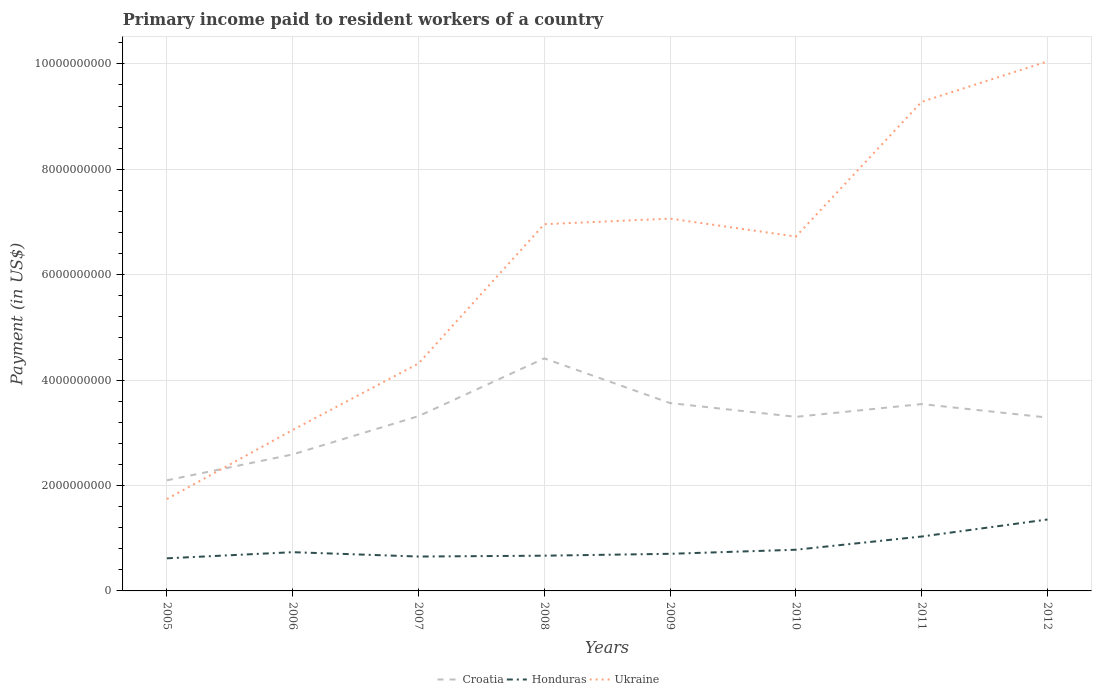How many different coloured lines are there?
Keep it short and to the point. 3. Is the number of lines equal to the number of legend labels?
Offer a terse response. Yes. Across all years, what is the maximum amount paid to workers in Ukraine?
Offer a very short reply. 1.74e+09. In which year was the amount paid to workers in Honduras maximum?
Make the answer very short. 2005. What is the total amount paid to workers in Ukraine in the graph?
Provide a succinct answer. -3.32e+09. What is the difference between the highest and the second highest amount paid to workers in Ukraine?
Your response must be concise. 8.30e+09. What is the difference between the highest and the lowest amount paid to workers in Honduras?
Ensure brevity in your answer.  2. How many years are there in the graph?
Offer a very short reply. 8. Are the values on the major ticks of Y-axis written in scientific E-notation?
Your answer should be compact. No. Does the graph contain any zero values?
Your response must be concise. No. How are the legend labels stacked?
Your answer should be compact. Horizontal. What is the title of the graph?
Your answer should be compact. Primary income paid to resident workers of a country. What is the label or title of the X-axis?
Your response must be concise. Years. What is the label or title of the Y-axis?
Keep it short and to the point. Payment (in US$). What is the Payment (in US$) in Croatia in 2005?
Your answer should be compact. 2.10e+09. What is the Payment (in US$) of Honduras in 2005?
Your answer should be compact. 6.19e+08. What is the Payment (in US$) of Ukraine in 2005?
Ensure brevity in your answer.  1.74e+09. What is the Payment (in US$) in Croatia in 2006?
Your answer should be compact. 2.59e+09. What is the Payment (in US$) of Honduras in 2006?
Offer a terse response. 7.35e+08. What is the Payment (in US$) in Ukraine in 2006?
Offer a very short reply. 3.05e+09. What is the Payment (in US$) in Croatia in 2007?
Your answer should be very brief. 3.32e+09. What is the Payment (in US$) of Honduras in 2007?
Keep it short and to the point. 6.52e+08. What is the Payment (in US$) in Ukraine in 2007?
Ensure brevity in your answer.  4.32e+09. What is the Payment (in US$) of Croatia in 2008?
Offer a terse response. 4.41e+09. What is the Payment (in US$) in Honduras in 2008?
Your response must be concise. 6.69e+08. What is the Payment (in US$) of Ukraine in 2008?
Give a very brief answer. 6.96e+09. What is the Payment (in US$) in Croatia in 2009?
Your response must be concise. 3.56e+09. What is the Payment (in US$) of Honduras in 2009?
Ensure brevity in your answer.  7.04e+08. What is the Payment (in US$) of Ukraine in 2009?
Provide a short and direct response. 7.06e+09. What is the Payment (in US$) of Croatia in 2010?
Offer a terse response. 3.30e+09. What is the Payment (in US$) of Honduras in 2010?
Offer a very short reply. 7.81e+08. What is the Payment (in US$) of Ukraine in 2010?
Make the answer very short. 6.72e+09. What is the Payment (in US$) in Croatia in 2011?
Offer a terse response. 3.55e+09. What is the Payment (in US$) of Honduras in 2011?
Offer a very short reply. 1.03e+09. What is the Payment (in US$) in Ukraine in 2011?
Give a very brief answer. 9.28e+09. What is the Payment (in US$) in Croatia in 2012?
Make the answer very short. 3.29e+09. What is the Payment (in US$) in Honduras in 2012?
Give a very brief answer. 1.36e+09. What is the Payment (in US$) of Ukraine in 2012?
Offer a very short reply. 1.00e+1. Across all years, what is the maximum Payment (in US$) of Croatia?
Your answer should be very brief. 4.41e+09. Across all years, what is the maximum Payment (in US$) of Honduras?
Your answer should be compact. 1.36e+09. Across all years, what is the maximum Payment (in US$) of Ukraine?
Provide a succinct answer. 1.00e+1. Across all years, what is the minimum Payment (in US$) of Croatia?
Give a very brief answer. 2.10e+09. Across all years, what is the minimum Payment (in US$) in Honduras?
Your answer should be very brief. 6.19e+08. Across all years, what is the minimum Payment (in US$) in Ukraine?
Provide a succinct answer. 1.74e+09. What is the total Payment (in US$) in Croatia in the graph?
Ensure brevity in your answer.  2.61e+1. What is the total Payment (in US$) in Honduras in the graph?
Your answer should be very brief. 6.55e+09. What is the total Payment (in US$) in Ukraine in the graph?
Your answer should be very brief. 4.92e+1. What is the difference between the Payment (in US$) in Croatia in 2005 and that in 2006?
Your response must be concise. -4.92e+08. What is the difference between the Payment (in US$) of Honduras in 2005 and that in 2006?
Offer a terse response. -1.16e+08. What is the difference between the Payment (in US$) in Ukraine in 2005 and that in 2006?
Provide a short and direct response. -1.31e+09. What is the difference between the Payment (in US$) in Croatia in 2005 and that in 2007?
Provide a succinct answer. -1.22e+09. What is the difference between the Payment (in US$) of Honduras in 2005 and that in 2007?
Your answer should be very brief. -3.38e+07. What is the difference between the Payment (in US$) in Ukraine in 2005 and that in 2007?
Your response must be concise. -2.57e+09. What is the difference between the Payment (in US$) of Croatia in 2005 and that in 2008?
Your answer should be compact. -2.31e+09. What is the difference between the Payment (in US$) of Honduras in 2005 and that in 2008?
Your answer should be very brief. -5.00e+07. What is the difference between the Payment (in US$) in Ukraine in 2005 and that in 2008?
Your answer should be very brief. -5.22e+09. What is the difference between the Payment (in US$) of Croatia in 2005 and that in 2009?
Your answer should be very brief. -1.47e+09. What is the difference between the Payment (in US$) of Honduras in 2005 and that in 2009?
Your response must be concise. -8.54e+07. What is the difference between the Payment (in US$) in Ukraine in 2005 and that in 2009?
Keep it short and to the point. -5.32e+09. What is the difference between the Payment (in US$) in Croatia in 2005 and that in 2010?
Your answer should be compact. -1.20e+09. What is the difference between the Payment (in US$) of Honduras in 2005 and that in 2010?
Offer a very short reply. -1.63e+08. What is the difference between the Payment (in US$) of Ukraine in 2005 and that in 2010?
Offer a terse response. -4.98e+09. What is the difference between the Payment (in US$) in Croatia in 2005 and that in 2011?
Offer a terse response. -1.45e+09. What is the difference between the Payment (in US$) in Honduras in 2005 and that in 2011?
Your response must be concise. -4.14e+08. What is the difference between the Payment (in US$) in Ukraine in 2005 and that in 2011?
Provide a succinct answer. -7.54e+09. What is the difference between the Payment (in US$) in Croatia in 2005 and that in 2012?
Your answer should be very brief. -1.19e+09. What is the difference between the Payment (in US$) in Honduras in 2005 and that in 2012?
Offer a terse response. -7.37e+08. What is the difference between the Payment (in US$) in Ukraine in 2005 and that in 2012?
Offer a terse response. -8.30e+09. What is the difference between the Payment (in US$) of Croatia in 2006 and that in 2007?
Ensure brevity in your answer.  -7.26e+08. What is the difference between the Payment (in US$) of Honduras in 2006 and that in 2007?
Your response must be concise. 8.26e+07. What is the difference between the Payment (in US$) of Ukraine in 2006 and that in 2007?
Keep it short and to the point. -1.26e+09. What is the difference between the Payment (in US$) in Croatia in 2006 and that in 2008?
Provide a succinct answer. -1.82e+09. What is the difference between the Payment (in US$) in Honduras in 2006 and that in 2008?
Your answer should be very brief. 6.64e+07. What is the difference between the Payment (in US$) in Ukraine in 2006 and that in 2008?
Give a very brief answer. -3.90e+09. What is the difference between the Payment (in US$) of Croatia in 2006 and that in 2009?
Give a very brief answer. -9.74e+08. What is the difference between the Payment (in US$) of Honduras in 2006 and that in 2009?
Offer a very short reply. 3.09e+07. What is the difference between the Payment (in US$) in Ukraine in 2006 and that in 2009?
Keep it short and to the point. -4.01e+09. What is the difference between the Payment (in US$) in Croatia in 2006 and that in 2010?
Your answer should be very brief. -7.13e+08. What is the difference between the Payment (in US$) of Honduras in 2006 and that in 2010?
Make the answer very short. -4.64e+07. What is the difference between the Payment (in US$) in Ukraine in 2006 and that in 2010?
Your answer should be very brief. -3.67e+09. What is the difference between the Payment (in US$) of Croatia in 2006 and that in 2011?
Your response must be concise. -9.55e+08. What is the difference between the Payment (in US$) in Honduras in 2006 and that in 2011?
Make the answer very short. -2.97e+08. What is the difference between the Payment (in US$) of Ukraine in 2006 and that in 2011?
Your answer should be compact. -6.23e+09. What is the difference between the Payment (in US$) in Croatia in 2006 and that in 2012?
Your answer should be compact. -7.00e+08. What is the difference between the Payment (in US$) of Honduras in 2006 and that in 2012?
Offer a terse response. -6.20e+08. What is the difference between the Payment (in US$) of Ukraine in 2006 and that in 2012?
Ensure brevity in your answer.  -6.99e+09. What is the difference between the Payment (in US$) in Croatia in 2007 and that in 2008?
Your answer should be compact. -1.10e+09. What is the difference between the Payment (in US$) of Honduras in 2007 and that in 2008?
Give a very brief answer. -1.62e+07. What is the difference between the Payment (in US$) in Ukraine in 2007 and that in 2008?
Offer a very short reply. -2.64e+09. What is the difference between the Payment (in US$) in Croatia in 2007 and that in 2009?
Give a very brief answer. -2.48e+08. What is the difference between the Payment (in US$) of Honduras in 2007 and that in 2009?
Offer a very short reply. -5.17e+07. What is the difference between the Payment (in US$) in Ukraine in 2007 and that in 2009?
Make the answer very short. -2.75e+09. What is the difference between the Payment (in US$) in Croatia in 2007 and that in 2010?
Offer a very short reply. 1.30e+07. What is the difference between the Payment (in US$) in Honduras in 2007 and that in 2010?
Make the answer very short. -1.29e+08. What is the difference between the Payment (in US$) of Ukraine in 2007 and that in 2010?
Offer a terse response. -2.41e+09. What is the difference between the Payment (in US$) in Croatia in 2007 and that in 2011?
Your answer should be very brief. -2.30e+08. What is the difference between the Payment (in US$) in Honduras in 2007 and that in 2011?
Your answer should be very brief. -3.80e+08. What is the difference between the Payment (in US$) of Ukraine in 2007 and that in 2011?
Your answer should be compact. -4.97e+09. What is the difference between the Payment (in US$) of Croatia in 2007 and that in 2012?
Offer a terse response. 2.61e+07. What is the difference between the Payment (in US$) in Honduras in 2007 and that in 2012?
Ensure brevity in your answer.  -7.03e+08. What is the difference between the Payment (in US$) of Ukraine in 2007 and that in 2012?
Provide a succinct answer. -5.73e+09. What is the difference between the Payment (in US$) in Croatia in 2008 and that in 2009?
Your response must be concise. 8.48e+08. What is the difference between the Payment (in US$) of Honduras in 2008 and that in 2009?
Ensure brevity in your answer.  -3.55e+07. What is the difference between the Payment (in US$) of Ukraine in 2008 and that in 2009?
Your answer should be very brief. -1.05e+08. What is the difference between the Payment (in US$) of Croatia in 2008 and that in 2010?
Your answer should be very brief. 1.11e+09. What is the difference between the Payment (in US$) of Honduras in 2008 and that in 2010?
Keep it short and to the point. -1.13e+08. What is the difference between the Payment (in US$) in Ukraine in 2008 and that in 2010?
Provide a succinct answer. 2.35e+08. What is the difference between the Payment (in US$) of Croatia in 2008 and that in 2011?
Offer a very short reply. 8.67e+08. What is the difference between the Payment (in US$) in Honduras in 2008 and that in 2011?
Keep it short and to the point. -3.64e+08. What is the difference between the Payment (in US$) of Ukraine in 2008 and that in 2011?
Your answer should be very brief. -2.32e+09. What is the difference between the Payment (in US$) in Croatia in 2008 and that in 2012?
Make the answer very short. 1.12e+09. What is the difference between the Payment (in US$) in Honduras in 2008 and that in 2012?
Your response must be concise. -6.87e+08. What is the difference between the Payment (in US$) of Ukraine in 2008 and that in 2012?
Make the answer very short. -3.09e+09. What is the difference between the Payment (in US$) of Croatia in 2009 and that in 2010?
Provide a short and direct response. 2.61e+08. What is the difference between the Payment (in US$) in Honduras in 2009 and that in 2010?
Your answer should be very brief. -7.73e+07. What is the difference between the Payment (in US$) in Ukraine in 2009 and that in 2010?
Make the answer very short. 3.40e+08. What is the difference between the Payment (in US$) of Croatia in 2009 and that in 2011?
Offer a terse response. 1.87e+07. What is the difference between the Payment (in US$) of Honduras in 2009 and that in 2011?
Offer a very short reply. -3.28e+08. What is the difference between the Payment (in US$) in Ukraine in 2009 and that in 2011?
Make the answer very short. -2.22e+09. What is the difference between the Payment (in US$) in Croatia in 2009 and that in 2012?
Offer a terse response. 2.74e+08. What is the difference between the Payment (in US$) in Honduras in 2009 and that in 2012?
Provide a succinct answer. -6.51e+08. What is the difference between the Payment (in US$) in Ukraine in 2009 and that in 2012?
Provide a succinct answer. -2.98e+09. What is the difference between the Payment (in US$) in Croatia in 2010 and that in 2011?
Your answer should be very brief. -2.43e+08. What is the difference between the Payment (in US$) of Honduras in 2010 and that in 2011?
Offer a very short reply. -2.51e+08. What is the difference between the Payment (in US$) in Ukraine in 2010 and that in 2011?
Keep it short and to the point. -2.56e+09. What is the difference between the Payment (in US$) in Croatia in 2010 and that in 2012?
Your answer should be compact. 1.30e+07. What is the difference between the Payment (in US$) of Honduras in 2010 and that in 2012?
Give a very brief answer. -5.74e+08. What is the difference between the Payment (in US$) of Ukraine in 2010 and that in 2012?
Provide a succinct answer. -3.32e+09. What is the difference between the Payment (in US$) in Croatia in 2011 and that in 2012?
Keep it short and to the point. 2.56e+08. What is the difference between the Payment (in US$) of Honduras in 2011 and that in 2012?
Your response must be concise. -3.23e+08. What is the difference between the Payment (in US$) in Ukraine in 2011 and that in 2012?
Provide a succinct answer. -7.66e+08. What is the difference between the Payment (in US$) of Croatia in 2005 and the Payment (in US$) of Honduras in 2006?
Your answer should be very brief. 1.36e+09. What is the difference between the Payment (in US$) of Croatia in 2005 and the Payment (in US$) of Ukraine in 2006?
Offer a very short reply. -9.55e+08. What is the difference between the Payment (in US$) of Honduras in 2005 and the Payment (in US$) of Ukraine in 2006?
Make the answer very short. -2.44e+09. What is the difference between the Payment (in US$) of Croatia in 2005 and the Payment (in US$) of Honduras in 2007?
Make the answer very short. 1.45e+09. What is the difference between the Payment (in US$) of Croatia in 2005 and the Payment (in US$) of Ukraine in 2007?
Ensure brevity in your answer.  -2.22e+09. What is the difference between the Payment (in US$) in Honduras in 2005 and the Payment (in US$) in Ukraine in 2007?
Keep it short and to the point. -3.70e+09. What is the difference between the Payment (in US$) in Croatia in 2005 and the Payment (in US$) in Honduras in 2008?
Your answer should be compact. 1.43e+09. What is the difference between the Payment (in US$) of Croatia in 2005 and the Payment (in US$) of Ukraine in 2008?
Provide a short and direct response. -4.86e+09. What is the difference between the Payment (in US$) in Honduras in 2005 and the Payment (in US$) in Ukraine in 2008?
Your answer should be very brief. -6.34e+09. What is the difference between the Payment (in US$) of Croatia in 2005 and the Payment (in US$) of Honduras in 2009?
Your response must be concise. 1.39e+09. What is the difference between the Payment (in US$) of Croatia in 2005 and the Payment (in US$) of Ukraine in 2009?
Your answer should be compact. -4.97e+09. What is the difference between the Payment (in US$) in Honduras in 2005 and the Payment (in US$) in Ukraine in 2009?
Your response must be concise. -6.45e+09. What is the difference between the Payment (in US$) in Croatia in 2005 and the Payment (in US$) in Honduras in 2010?
Offer a terse response. 1.32e+09. What is the difference between the Payment (in US$) of Croatia in 2005 and the Payment (in US$) of Ukraine in 2010?
Your response must be concise. -4.63e+09. What is the difference between the Payment (in US$) in Honduras in 2005 and the Payment (in US$) in Ukraine in 2010?
Your response must be concise. -6.11e+09. What is the difference between the Payment (in US$) of Croatia in 2005 and the Payment (in US$) of Honduras in 2011?
Your answer should be compact. 1.07e+09. What is the difference between the Payment (in US$) of Croatia in 2005 and the Payment (in US$) of Ukraine in 2011?
Make the answer very short. -7.18e+09. What is the difference between the Payment (in US$) in Honduras in 2005 and the Payment (in US$) in Ukraine in 2011?
Your response must be concise. -8.66e+09. What is the difference between the Payment (in US$) of Croatia in 2005 and the Payment (in US$) of Honduras in 2012?
Your response must be concise. 7.43e+08. What is the difference between the Payment (in US$) of Croatia in 2005 and the Payment (in US$) of Ukraine in 2012?
Provide a succinct answer. -7.95e+09. What is the difference between the Payment (in US$) in Honduras in 2005 and the Payment (in US$) in Ukraine in 2012?
Your response must be concise. -9.43e+09. What is the difference between the Payment (in US$) in Croatia in 2006 and the Payment (in US$) in Honduras in 2007?
Keep it short and to the point. 1.94e+09. What is the difference between the Payment (in US$) in Croatia in 2006 and the Payment (in US$) in Ukraine in 2007?
Make the answer very short. -1.72e+09. What is the difference between the Payment (in US$) of Honduras in 2006 and the Payment (in US$) of Ukraine in 2007?
Your answer should be compact. -3.58e+09. What is the difference between the Payment (in US$) in Croatia in 2006 and the Payment (in US$) in Honduras in 2008?
Make the answer very short. 1.92e+09. What is the difference between the Payment (in US$) of Croatia in 2006 and the Payment (in US$) of Ukraine in 2008?
Provide a succinct answer. -4.37e+09. What is the difference between the Payment (in US$) in Honduras in 2006 and the Payment (in US$) in Ukraine in 2008?
Ensure brevity in your answer.  -6.22e+09. What is the difference between the Payment (in US$) of Croatia in 2006 and the Payment (in US$) of Honduras in 2009?
Your answer should be compact. 1.89e+09. What is the difference between the Payment (in US$) of Croatia in 2006 and the Payment (in US$) of Ukraine in 2009?
Offer a terse response. -4.47e+09. What is the difference between the Payment (in US$) of Honduras in 2006 and the Payment (in US$) of Ukraine in 2009?
Your response must be concise. -6.33e+09. What is the difference between the Payment (in US$) of Croatia in 2006 and the Payment (in US$) of Honduras in 2010?
Offer a very short reply. 1.81e+09. What is the difference between the Payment (in US$) of Croatia in 2006 and the Payment (in US$) of Ukraine in 2010?
Offer a terse response. -4.13e+09. What is the difference between the Payment (in US$) of Honduras in 2006 and the Payment (in US$) of Ukraine in 2010?
Make the answer very short. -5.99e+09. What is the difference between the Payment (in US$) of Croatia in 2006 and the Payment (in US$) of Honduras in 2011?
Give a very brief answer. 1.56e+09. What is the difference between the Payment (in US$) of Croatia in 2006 and the Payment (in US$) of Ukraine in 2011?
Provide a succinct answer. -6.69e+09. What is the difference between the Payment (in US$) in Honduras in 2006 and the Payment (in US$) in Ukraine in 2011?
Your response must be concise. -8.55e+09. What is the difference between the Payment (in US$) in Croatia in 2006 and the Payment (in US$) in Honduras in 2012?
Ensure brevity in your answer.  1.23e+09. What is the difference between the Payment (in US$) in Croatia in 2006 and the Payment (in US$) in Ukraine in 2012?
Give a very brief answer. -7.46e+09. What is the difference between the Payment (in US$) in Honduras in 2006 and the Payment (in US$) in Ukraine in 2012?
Offer a terse response. -9.31e+09. What is the difference between the Payment (in US$) of Croatia in 2007 and the Payment (in US$) of Honduras in 2008?
Keep it short and to the point. 2.65e+09. What is the difference between the Payment (in US$) of Croatia in 2007 and the Payment (in US$) of Ukraine in 2008?
Give a very brief answer. -3.64e+09. What is the difference between the Payment (in US$) in Honduras in 2007 and the Payment (in US$) in Ukraine in 2008?
Offer a terse response. -6.31e+09. What is the difference between the Payment (in US$) in Croatia in 2007 and the Payment (in US$) in Honduras in 2009?
Ensure brevity in your answer.  2.61e+09. What is the difference between the Payment (in US$) of Croatia in 2007 and the Payment (in US$) of Ukraine in 2009?
Keep it short and to the point. -3.75e+09. What is the difference between the Payment (in US$) of Honduras in 2007 and the Payment (in US$) of Ukraine in 2009?
Your response must be concise. -6.41e+09. What is the difference between the Payment (in US$) in Croatia in 2007 and the Payment (in US$) in Honduras in 2010?
Give a very brief answer. 2.53e+09. What is the difference between the Payment (in US$) of Croatia in 2007 and the Payment (in US$) of Ukraine in 2010?
Offer a terse response. -3.41e+09. What is the difference between the Payment (in US$) of Honduras in 2007 and the Payment (in US$) of Ukraine in 2010?
Your answer should be very brief. -6.07e+09. What is the difference between the Payment (in US$) in Croatia in 2007 and the Payment (in US$) in Honduras in 2011?
Make the answer very short. 2.28e+09. What is the difference between the Payment (in US$) in Croatia in 2007 and the Payment (in US$) in Ukraine in 2011?
Your answer should be very brief. -5.97e+09. What is the difference between the Payment (in US$) in Honduras in 2007 and the Payment (in US$) in Ukraine in 2011?
Provide a succinct answer. -8.63e+09. What is the difference between the Payment (in US$) in Croatia in 2007 and the Payment (in US$) in Honduras in 2012?
Keep it short and to the point. 1.96e+09. What is the difference between the Payment (in US$) of Croatia in 2007 and the Payment (in US$) of Ukraine in 2012?
Offer a very short reply. -6.73e+09. What is the difference between the Payment (in US$) in Honduras in 2007 and the Payment (in US$) in Ukraine in 2012?
Ensure brevity in your answer.  -9.39e+09. What is the difference between the Payment (in US$) of Croatia in 2008 and the Payment (in US$) of Honduras in 2009?
Your answer should be very brief. 3.71e+09. What is the difference between the Payment (in US$) of Croatia in 2008 and the Payment (in US$) of Ukraine in 2009?
Offer a very short reply. -2.65e+09. What is the difference between the Payment (in US$) in Honduras in 2008 and the Payment (in US$) in Ukraine in 2009?
Your answer should be very brief. -6.40e+09. What is the difference between the Payment (in US$) in Croatia in 2008 and the Payment (in US$) in Honduras in 2010?
Ensure brevity in your answer.  3.63e+09. What is the difference between the Payment (in US$) in Croatia in 2008 and the Payment (in US$) in Ukraine in 2010?
Your response must be concise. -2.31e+09. What is the difference between the Payment (in US$) in Honduras in 2008 and the Payment (in US$) in Ukraine in 2010?
Provide a succinct answer. -6.06e+09. What is the difference between the Payment (in US$) in Croatia in 2008 and the Payment (in US$) in Honduras in 2011?
Keep it short and to the point. 3.38e+09. What is the difference between the Payment (in US$) in Croatia in 2008 and the Payment (in US$) in Ukraine in 2011?
Keep it short and to the point. -4.87e+09. What is the difference between the Payment (in US$) of Honduras in 2008 and the Payment (in US$) of Ukraine in 2011?
Offer a terse response. -8.61e+09. What is the difference between the Payment (in US$) in Croatia in 2008 and the Payment (in US$) in Honduras in 2012?
Your answer should be very brief. 3.06e+09. What is the difference between the Payment (in US$) in Croatia in 2008 and the Payment (in US$) in Ukraine in 2012?
Provide a succinct answer. -5.63e+09. What is the difference between the Payment (in US$) in Honduras in 2008 and the Payment (in US$) in Ukraine in 2012?
Provide a short and direct response. -9.38e+09. What is the difference between the Payment (in US$) of Croatia in 2009 and the Payment (in US$) of Honduras in 2010?
Offer a very short reply. 2.78e+09. What is the difference between the Payment (in US$) of Croatia in 2009 and the Payment (in US$) of Ukraine in 2010?
Offer a terse response. -3.16e+09. What is the difference between the Payment (in US$) of Honduras in 2009 and the Payment (in US$) of Ukraine in 2010?
Ensure brevity in your answer.  -6.02e+09. What is the difference between the Payment (in US$) in Croatia in 2009 and the Payment (in US$) in Honduras in 2011?
Provide a short and direct response. 2.53e+09. What is the difference between the Payment (in US$) of Croatia in 2009 and the Payment (in US$) of Ukraine in 2011?
Your answer should be very brief. -5.72e+09. What is the difference between the Payment (in US$) of Honduras in 2009 and the Payment (in US$) of Ukraine in 2011?
Your answer should be very brief. -8.58e+09. What is the difference between the Payment (in US$) of Croatia in 2009 and the Payment (in US$) of Honduras in 2012?
Your answer should be compact. 2.21e+09. What is the difference between the Payment (in US$) in Croatia in 2009 and the Payment (in US$) in Ukraine in 2012?
Offer a terse response. -6.48e+09. What is the difference between the Payment (in US$) of Honduras in 2009 and the Payment (in US$) of Ukraine in 2012?
Offer a terse response. -9.34e+09. What is the difference between the Payment (in US$) in Croatia in 2010 and the Payment (in US$) in Honduras in 2011?
Provide a short and direct response. 2.27e+09. What is the difference between the Payment (in US$) in Croatia in 2010 and the Payment (in US$) in Ukraine in 2011?
Your response must be concise. -5.98e+09. What is the difference between the Payment (in US$) of Honduras in 2010 and the Payment (in US$) of Ukraine in 2011?
Offer a very short reply. -8.50e+09. What is the difference between the Payment (in US$) in Croatia in 2010 and the Payment (in US$) in Honduras in 2012?
Offer a terse response. 1.95e+09. What is the difference between the Payment (in US$) of Croatia in 2010 and the Payment (in US$) of Ukraine in 2012?
Provide a succinct answer. -6.74e+09. What is the difference between the Payment (in US$) of Honduras in 2010 and the Payment (in US$) of Ukraine in 2012?
Your answer should be very brief. -9.27e+09. What is the difference between the Payment (in US$) in Croatia in 2011 and the Payment (in US$) in Honduras in 2012?
Your answer should be compact. 2.19e+09. What is the difference between the Payment (in US$) of Croatia in 2011 and the Payment (in US$) of Ukraine in 2012?
Your answer should be compact. -6.50e+09. What is the difference between the Payment (in US$) of Honduras in 2011 and the Payment (in US$) of Ukraine in 2012?
Offer a very short reply. -9.01e+09. What is the average Payment (in US$) in Croatia per year?
Your answer should be very brief. 3.26e+09. What is the average Payment (in US$) of Honduras per year?
Give a very brief answer. 8.19e+08. What is the average Payment (in US$) in Ukraine per year?
Make the answer very short. 6.15e+09. In the year 2005, what is the difference between the Payment (in US$) in Croatia and Payment (in US$) in Honduras?
Your answer should be compact. 1.48e+09. In the year 2005, what is the difference between the Payment (in US$) in Croatia and Payment (in US$) in Ukraine?
Keep it short and to the point. 3.56e+08. In the year 2005, what is the difference between the Payment (in US$) of Honduras and Payment (in US$) of Ukraine?
Offer a very short reply. -1.12e+09. In the year 2006, what is the difference between the Payment (in US$) in Croatia and Payment (in US$) in Honduras?
Your answer should be compact. 1.86e+09. In the year 2006, what is the difference between the Payment (in US$) of Croatia and Payment (in US$) of Ukraine?
Give a very brief answer. -4.64e+08. In the year 2006, what is the difference between the Payment (in US$) in Honduras and Payment (in US$) in Ukraine?
Offer a terse response. -2.32e+09. In the year 2007, what is the difference between the Payment (in US$) in Croatia and Payment (in US$) in Honduras?
Offer a very short reply. 2.66e+09. In the year 2007, what is the difference between the Payment (in US$) of Croatia and Payment (in US$) of Ukraine?
Give a very brief answer. -9.99e+08. In the year 2007, what is the difference between the Payment (in US$) in Honduras and Payment (in US$) in Ukraine?
Your answer should be compact. -3.66e+09. In the year 2008, what is the difference between the Payment (in US$) in Croatia and Payment (in US$) in Honduras?
Your response must be concise. 3.74e+09. In the year 2008, what is the difference between the Payment (in US$) in Croatia and Payment (in US$) in Ukraine?
Your answer should be very brief. -2.55e+09. In the year 2008, what is the difference between the Payment (in US$) in Honduras and Payment (in US$) in Ukraine?
Ensure brevity in your answer.  -6.29e+09. In the year 2009, what is the difference between the Payment (in US$) of Croatia and Payment (in US$) of Honduras?
Make the answer very short. 2.86e+09. In the year 2009, what is the difference between the Payment (in US$) in Croatia and Payment (in US$) in Ukraine?
Provide a succinct answer. -3.50e+09. In the year 2009, what is the difference between the Payment (in US$) in Honduras and Payment (in US$) in Ukraine?
Provide a succinct answer. -6.36e+09. In the year 2010, what is the difference between the Payment (in US$) of Croatia and Payment (in US$) of Honduras?
Your answer should be compact. 2.52e+09. In the year 2010, what is the difference between the Payment (in US$) of Croatia and Payment (in US$) of Ukraine?
Offer a terse response. -3.42e+09. In the year 2010, what is the difference between the Payment (in US$) in Honduras and Payment (in US$) in Ukraine?
Provide a short and direct response. -5.94e+09. In the year 2011, what is the difference between the Payment (in US$) in Croatia and Payment (in US$) in Honduras?
Offer a very short reply. 2.51e+09. In the year 2011, what is the difference between the Payment (in US$) of Croatia and Payment (in US$) of Ukraine?
Provide a succinct answer. -5.74e+09. In the year 2011, what is the difference between the Payment (in US$) in Honduras and Payment (in US$) in Ukraine?
Your response must be concise. -8.25e+09. In the year 2012, what is the difference between the Payment (in US$) in Croatia and Payment (in US$) in Honduras?
Provide a short and direct response. 1.93e+09. In the year 2012, what is the difference between the Payment (in US$) of Croatia and Payment (in US$) of Ukraine?
Your response must be concise. -6.76e+09. In the year 2012, what is the difference between the Payment (in US$) of Honduras and Payment (in US$) of Ukraine?
Offer a very short reply. -8.69e+09. What is the ratio of the Payment (in US$) of Croatia in 2005 to that in 2006?
Provide a succinct answer. 0.81. What is the ratio of the Payment (in US$) in Honduras in 2005 to that in 2006?
Make the answer very short. 0.84. What is the ratio of the Payment (in US$) in Ukraine in 2005 to that in 2006?
Make the answer very short. 0.57. What is the ratio of the Payment (in US$) of Croatia in 2005 to that in 2007?
Ensure brevity in your answer.  0.63. What is the ratio of the Payment (in US$) in Honduras in 2005 to that in 2007?
Provide a succinct answer. 0.95. What is the ratio of the Payment (in US$) in Ukraine in 2005 to that in 2007?
Provide a short and direct response. 0.4. What is the ratio of the Payment (in US$) of Croatia in 2005 to that in 2008?
Your response must be concise. 0.48. What is the ratio of the Payment (in US$) in Honduras in 2005 to that in 2008?
Make the answer very short. 0.93. What is the ratio of the Payment (in US$) in Ukraine in 2005 to that in 2008?
Give a very brief answer. 0.25. What is the ratio of the Payment (in US$) of Croatia in 2005 to that in 2009?
Offer a very short reply. 0.59. What is the ratio of the Payment (in US$) of Honduras in 2005 to that in 2009?
Your answer should be compact. 0.88. What is the ratio of the Payment (in US$) in Ukraine in 2005 to that in 2009?
Offer a very short reply. 0.25. What is the ratio of the Payment (in US$) of Croatia in 2005 to that in 2010?
Ensure brevity in your answer.  0.64. What is the ratio of the Payment (in US$) in Honduras in 2005 to that in 2010?
Offer a very short reply. 0.79. What is the ratio of the Payment (in US$) of Ukraine in 2005 to that in 2010?
Make the answer very short. 0.26. What is the ratio of the Payment (in US$) of Croatia in 2005 to that in 2011?
Offer a very short reply. 0.59. What is the ratio of the Payment (in US$) of Honduras in 2005 to that in 2011?
Offer a terse response. 0.6. What is the ratio of the Payment (in US$) in Ukraine in 2005 to that in 2011?
Make the answer very short. 0.19. What is the ratio of the Payment (in US$) in Croatia in 2005 to that in 2012?
Make the answer very short. 0.64. What is the ratio of the Payment (in US$) in Honduras in 2005 to that in 2012?
Offer a terse response. 0.46. What is the ratio of the Payment (in US$) in Ukraine in 2005 to that in 2012?
Offer a terse response. 0.17. What is the ratio of the Payment (in US$) of Croatia in 2006 to that in 2007?
Offer a terse response. 0.78. What is the ratio of the Payment (in US$) in Honduras in 2006 to that in 2007?
Your answer should be very brief. 1.13. What is the ratio of the Payment (in US$) in Ukraine in 2006 to that in 2007?
Offer a terse response. 0.71. What is the ratio of the Payment (in US$) of Croatia in 2006 to that in 2008?
Make the answer very short. 0.59. What is the ratio of the Payment (in US$) in Honduras in 2006 to that in 2008?
Your response must be concise. 1.1. What is the ratio of the Payment (in US$) of Ukraine in 2006 to that in 2008?
Give a very brief answer. 0.44. What is the ratio of the Payment (in US$) of Croatia in 2006 to that in 2009?
Ensure brevity in your answer.  0.73. What is the ratio of the Payment (in US$) of Honduras in 2006 to that in 2009?
Offer a very short reply. 1.04. What is the ratio of the Payment (in US$) in Ukraine in 2006 to that in 2009?
Your response must be concise. 0.43. What is the ratio of the Payment (in US$) of Croatia in 2006 to that in 2010?
Give a very brief answer. 0.78. What is the ratio of the Payment (in US$) of Honduras in 2006 to that in 2010?
Your answer should be compact. 0.94. What is the ratio of the Payment (in US$) of Ukraine in 2006 to that in 2010?
Provide a succinct answer. 0.45. What is the ratio of the Payment (in US$) in Croatia in 2006 to that in 2011?
Offer a very short reply. 0.73. What is the ratio of the Payment (in US$) in Honduras in 2006 to that in 2011?
Offer a terse response. 0.71. What is the ratio of the Payment (in US$) of Ukraine in 2006 to that in 2011?
Your answer should be very brief. 0.33. What is the ratio of the Payment (in US$) in Croatia in 2006 to that in 2012?
Provide a short and direct response. 0.79. What is the ratio of the Payment (in US$) in Honduras in 2006 to that in 2012?
Offer a very short reply. 0.54. What is the ratio of the Payment (in US$) in Ukraine in 2006 to that in 2012?
Give a very brief answer. 0.3. What is the ratio of the Payment (in US$) in Croatia in 2007 to that in 2008?
Ensure brevity in your answer.  0.75. What is the ratio of the Payment (in US$) of Honduras in 2007 to that in 2008?
Provide a succinct answer. 0.98. What is the ratio of the Payment (in US$) in Ukraine in 2007 to that in 2008?
Your response must be concise. 0.62. What is the ratio of the Payment (in US$) in Croatia in 2007 to that in 2009?
Offer a terse response. 0.93. What is the ratio of the Payment (in US$) of Honduras in 2007 to that in 2009?
Your answer should be compact. 0.93. What is the ratio of the Payment (in US$) of Ukraine in 2007 to that in 2009?
Keep it short and to the point. 0.61. What is the ratio of the Payment (in US$) in Croatia in 2007 to that in 2010?
Offer a very short reply. 1. What is the ratio of the Payment (in US$) of Honduras in 2007 to that in 2010?
Provide a succinct answer. 0.83. What is the ratio of the Payment (in US$) of Ukraine in 2007 to that in 2010?
Provide a short and direct response. 0.64. What is the ratio of the Payment (in US$) of Croatia in 2007 to that in 2011?
Your answer should be compact. 0.94. What is the ratio of the Payment (in US$) in Honduras in 2007 to that in 2011?
Give a very brief answer. 0.63. What is the ratio of the Payment (in US$) of Ukraine in 2007 to that in 2011?
Provide a succinct answer. 0.46. What is the ratio of the Payment (in US$) of Croatia in 2007 to that in 2012?
Keep it short and to the point. 1.01. What is the ratio of the Payment (in US$) in Honduras in 2007 to that in 2012?
Offer a very short reply. 0.48. What is the ratio of the Payment (in US$) in Ukraine in 2007 to that in 2012?
Provide a short and direct response. 0.43. What is the ratio of the Payment (in US$) of Croatia in 2008 to that in 2009?
Provide a short and direct response. 1.24. What is the ratio of the Payment (in US$) in Honduras in 2008 to that in 2009?
Offer a very short reply. 0.95. What is the ratio of the Payment (in US$) in Ukraine in 2008 to that in 2009?
Give a very brief answer. 0.99. What is the ratio of the Payment (in US$) in Croatia in 2008 to that in 2010?
Provide a short and direct response. 1.34. What is the ratio of the Payment (in US$) in Honduras in 2008 to that in 2010?
Offer a terse response. 0.86. What is the ratio of the Payment (in US$) in Ukraine in 2008 to that in 2010?
Offer a terse response. 1.03. What is the ratio of the Payment (in US$) of Croatia in 2008 to that in 2011?
Provide a succinct answer. 1.24. What is the ratio of the Payment (in US$) of Honduras in 2008 to that in 2011?
Ensure brevity in your answer.  0.65. What is the ratio of the Payment (in US$) in Ukraine in 2008 to that in 2011?
Make the answer very short. 0.75. What is the ratio of the Payment (in US$) of Croatia in 2008 to that in 2012?
Give a very brief answer. 1.34. What is the ratio of the Payment (in US$) in Honduras in 2008 to that in 2012?
Your answer should be compact. 0.49. What is the ratio of the Payment (in US$) of Ukraine in 2008 to that in 2012?
Make the answer very short. 0.69. What is the ratio of the Payment (in US$) in Croatia in 2009 to that in 2010?
Offer a very short reply. 1.08. What is the ratio of the Payment (in US$) in Honduras in 2009 to that in 2010?
Keep it short and to the point. 0.9. What is the ratio of the Payment (in US$) in Ukraine in 2009 to that in 2010?
Provide a short and direct response. 1.05. What is the ratio of the Payment (in US$) in Croatia in 2009 to that in 2011?
Offer a very short reply. 1.01. What is the ratio of the Payment (in US$) in Honduras in 2009 to that in 2011?
Give a very brief answer. 0.68. What is the ratio of the Payment (in US$) in Ukraine in 2009 to that in 2011?
Your response must be concise. 0.76. What is the ratio of the Payment (in US$) of Croatia in 2009 to that in 2012?
Provide a short and direct response. 1.08. What is the ratio of the Payment (in US$) in Honduras in 2009 to that in 2012?
Your answer should be compact. 0.52. What is the ratio of the Payment (in US$) in Ukraine in 2009 to that in 2012?
Your answer should be compact. 0.7. What is the ratio of the Payment (in US$) in Croatia in 2010 to that in 2011?
Offer a very short reply. 0.93. What is the ratio of the Payment (in US$) of Honduras in 2010 to that in 2011?
Your answer should be compact. 0.76. What is the ratio of the Payment (in US$) in Ukraine in 2010 to that in 2011?
Offer a very short reply. 0.72. What is the ratio of the Payment (in US$) in Honduras in 2010 to that in 2012?
Provide a short and direct response. 0.58. What is the ratio of the Payment (in US$) in Ukraine in 2010 to that in 2012?
Offer a terse response. 0.67. What is the ratio of the Payment (in US$) of Croatia in 2011 to that in 2012?
Offer a very short reply. 1.08. What is the ratio of the Payment (in US$) of Honduras in 2011 to that in 2012?
Your answer should be very brief. 0.76. What is the ratio of the Payment (in US$) in Ukraine in 2011 to that in 2012?
Ensure brevity in your answer.  0.92. What is the difference between the highest and the second highest Payment (in US$) of Croatia?
Ensure brevity in your answer.  8.48e+08. What is the difference between the highest and the second highest Payment (in US$) in Honduras?
Offer a terse response. 3.23e+08. What is the difference between the highest and the second highest Payment (in US$) of Ukraine?
Your answer should be very brief. 7.66e+08. What is the difference between the highest and the lowest Payment (in US$) of Croatia?
Give a very brief answer. 2.31e+09. What is the difference between the highest and the lowest Payment (in US$) in Honduras?
Your response must be concise. 7.37e+08. What is the difference between the highest and the lowest Payment (in US$) of Ukraine?
Offer a terse response. 8.30e+09. 